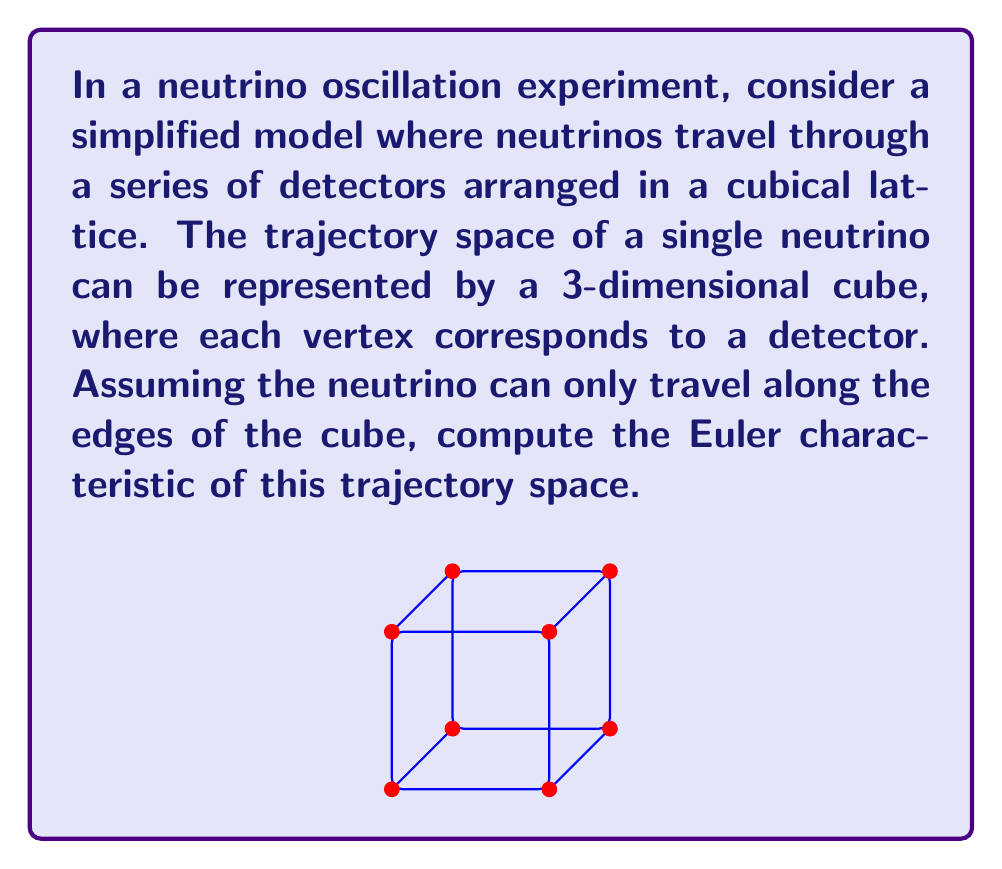Solve this math problem. To compute the Euler characteristic of the neutrino trajectory space, we need to count the number of vertices, edges, and faces in the cube. Let's break it down step-by-step:

1. Count the vertices:
   The cube has 8 vertices (2^3, as each dimension has 2 possible values).

2. Count the edges:
   Each edge of the cube represents a possible path for the neutrino.
   There are 12 edges in total (4 edges parallel to each of the 3 axes).

3. Count the faces:
   The cube has 6 faces (2 for each dimension).

4. Apply the Euler characteristic formula:
   The Euler characteristic χ is defined as:
   
   $$χ = V - E + F$$
   
   where V is the number of vertices, E is the number of edges, and F is the number of faces.

5. Substitute the values:
   $$χ = 8 - 12 + 6$$

6. Calculate:
   $$χ = 2$$

This result is consistent with the fact that the Euler characteristic of a solid cube (and any topological sphere) is 2.

For a particle physicist studying neutrinos, this simplified model provides insight into the topological properties of the trajectory space in a cubic detector arrangement, which could be relevant for understanding the geometry of neutrino paths in more complex experimental setups.
Answer: $χ = 2$ 